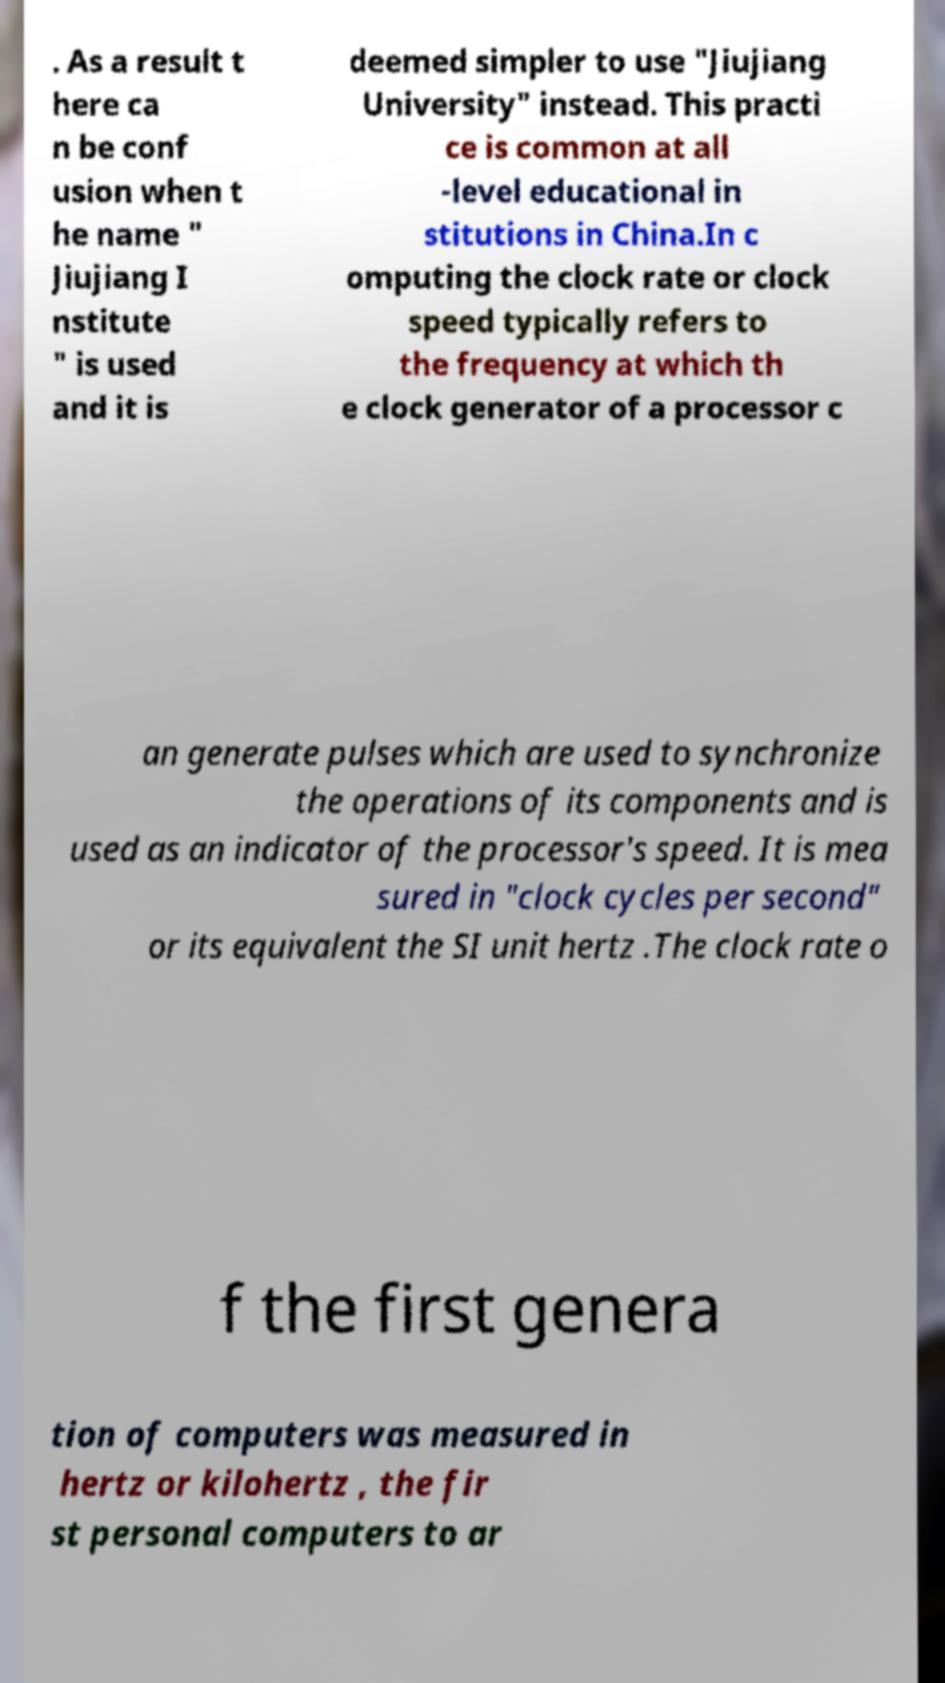I need the written content from this picture converted into text. Can you do that? . As a result t here ca n be conf usion when t he name " Jiujiang I nstitute " is used and it is deemed simpler to use "Jiujiang University" instead. This practi ce is common at all -level educational in stitutions in China.In c omputing the clock rate or clock speed typically refers to the frequency at which th e clock generator of a processor c an generate pulses which are used to synchronize the operations of its components and is used as an indicator of the processor's speed. It is mea sured in "clock cycles per second" or its equivalent the SI unit hertz .The clock rate o f the first genera tion of computers was measured in hertz or kilohertz , the fir st personal computers to ar 